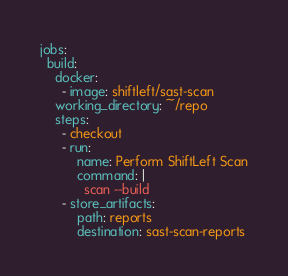Convert code to text. <code><loc_0><loc_0><loc_500><loc_500><_YAML_>jobs:
  build:
    docker:
      - image: shiftleft/sast-scan
    working_directory: ~/repo
    steps:
      - checkout
      - run:
          name: Perform ShiftLeft Scan
          command: |
            scan --build
      - store_artifacts:
          path: reports
          destination: sast-scan-reports
</code> 